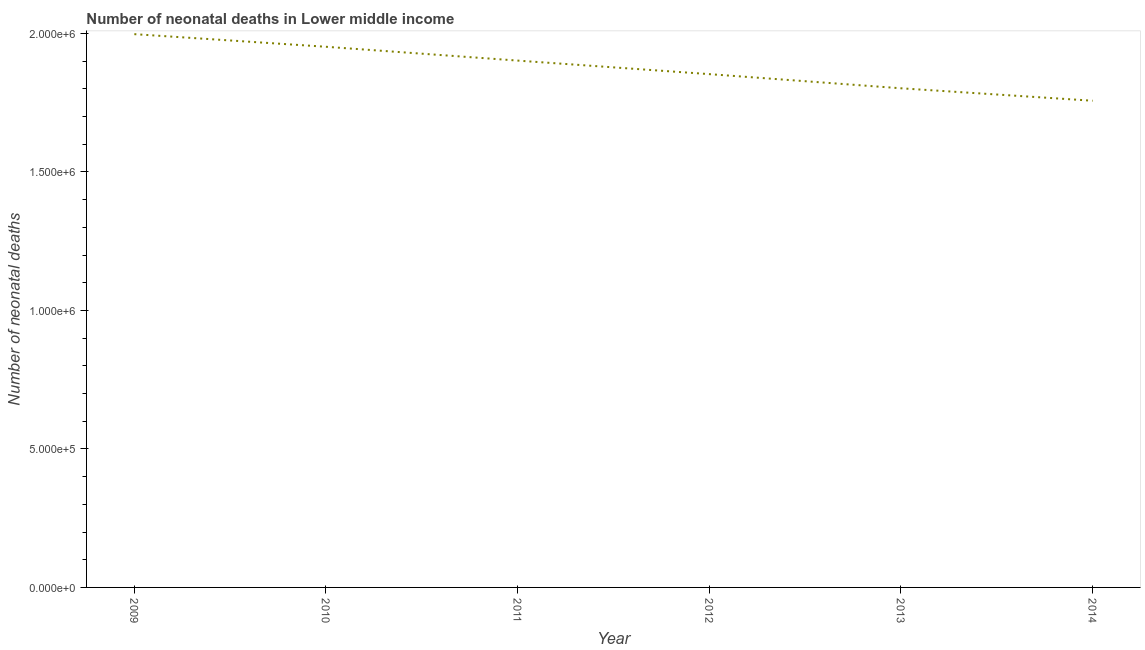What is the number of neonatal deaths in 2014?
Make the answer very short. 1.76e+06. Across all years, what is the maximum number of neonatal deaths?
Make the answer very short. 2.00e+06. Across all years, what is the minimum number of neonatal deaths?
Offer a very short reply. 1.76e+06. In which year was the number of neonatal deaths maximum?
Ensure brevity in your answer.  2009. In which year was the number of neonatal deaths minimum?
Offer a very short reply. 2014. What is the sum of the number of neonatal deaths?
Give a very brief answer. 1.13e+07. What is the difference between the number of neonatal deaths in 2010 and 2014?
Your response must be concise. 1.95e+05. What is the average number of neonatal deaths per year?
Your answer should be very brief. 1.88e+06. What is the median number of neonatal deaths?
Offer a very short reply. 1.88e+06. What is the ratio of the number of neonatal deaths in 2012 to that in 2013?
Provide a short and direct response. 1.03. Is the number of neonatal deaths in 2009 less than that in 2013?
Make the answer very short. No. What is the difference between the highest and the second highest number of neonatal deaths?
Provide a succinct answer. 4.56e+04. Is the sum of the number of neonatal deaths in 2011 and 2013 greater than the maximum number of neonatal deaths across all years?
Your answer should be compact. Yes. What is the difference between the highest and the lowest number of neonatal deaths?
Offer a terse response. 2.40e+05. Does the number of neonatal deaths monotonically increase over the years?
Provide a succinct answer. No. How many lines are there?
Offer a terse response. 1. How many years are there in the graph?
Keep it short and to the point. 6. What is the difference between two consecutive major ticks on the Y-axis?
Your response must be concise. 5.00e+05. Does the graph contain any zero values?
Your response must be concise. No. What is the title of the graph?
Provide a short and direct response. Number of neonatal deaths in Lower middle income. What is the label or title of the X-axis?
Provide a short and direct response. Year. What is the label or title of the Y-axis?
Offer a terse response. Number of neonatal deaths. What is the Number of neonatal deaths in 2009?
Provide a short and direct response. 2.00e+06. What is the Number of neonatal deaths in 2010?
Your answer should be compact. 1.95e+06. What is the Number of neonatal deaths of 2011?
Offer a terse response. 1.90e+06. What is the Number of neonatal deaths of 2012?
Keep it short and to the point. 1.85e+06. What is the Number of neonatal deaths of 2013?
Provide a short and direct response. 1.80e+06. What is the Number of neonatal deaths in 2014?
Ensure brevity in your answer.  1.76e+06. What is the difference between the Number of neonatal deaths in 2009 and 2010?
Ensure brevity in your answer.  4.56e+04. What is the difference between the Number of neonatal deaths in 2009 and 2011?
Provide a short and direct response. 9.54e+04. What is the difference between the Number of neonatal deaths in 2009 and 2012?
Your response must be concise. 1.44e+05. What is the difference between the Number of neonatal deaths in 2009 and 2013?
Provide a succinct answer. 1.95e+05. What is the difference between the Number of neonatal deaths in 2009 and 2014?
Keep it short and to the point. 2.40e+05. What is the difference between the Number of neonatal deaths in 2010 and 2011?
Offer a terse response. 4.99e+04. What is the difference between the Number of neonatal deaths in 2010 and 2012?
Give a very brief answer. 9.88e+04. What is the difference between the Number of neonatal deaths in 2010 and 2013?
Keep it short and to the point. 1.50e+05. What is the difference between the Number of neonatal deaths in 2010 and 2014?
Your answer should be very brief. 1.95e+05. What is the difference between the Number of neonatal deaths in 2011 and 2012?
Your response must be concise. 4.89e+04. What is the difference between the Number of neonatal deaths in 2011 and 2013?
Your response must be concise. 1.00e+05. What is the difference between the Number of neonatal deaths in 2011 and 2014?
Your answer should be very brief. 1.45e+05. What is the difference between the Number of neonatal deaths in 2012 and 2013?
Offer a very short reply. 5.11e+04. What is the difference between the Number of neonatal deaths in 2012 and 2014?
Offer a terse response. 9.60e+04. What is the difference between the Number of neonatal deaths in 2013 and 2014?
Give a very brief answer. 4.49e+04. What is the ratio of the Number of neonatal deaths in 2009 to that in 2012?
Offer a very short reply. 1.08. What is the ratio of the Number of neonatal deaths in 2009 to that in 2013?
Ensure brevity in your answer.  1.11. What is the ratio of the Number of neonatal deaths in 2009 to that in 2014?
Make the answer very short. 1.14. What is the ratio of the Number of neonatal deaths in 2010 to that in 2011?
Your response must be concise. 1.03. What is the ratio of the Number of neonatal deaths in 2010 to that in 2012?
Give a very brief answer. 1.05. What is the ratio of the Number of neonatal deaths in 2010 to that in 2013?
Keep it short and to the point. 1.08. What is the ratio of the Number of neonatal deaths in 2010 to that in 2014?
Your answer should be compact. 1.11. What is the ratio of the Number of neonatal deaths in 2011 to that in 2012?
Your answer should be very brief. 1.03. What is the ratio of the Number of neonatal deaths in 2011 to that in 2013?
Offer a very short reply. 1.05. What is the ratio of the Number of neonatal deaths in 2011 to that in 2014?
Offer a very short reply. 1.08. What is the ratio of the Number of neonatal deaths in 2012 to that in 2013?
Your response must be concise. 1.03. What is the ratio of the Number of neonatal deaths in 2012 to that in 2014?
Keep it short and to the point. 1.05. What is the ratio of the Number of neonatal deaths in 2013 to that in 2014?
Offer a terse response. 1.03. 